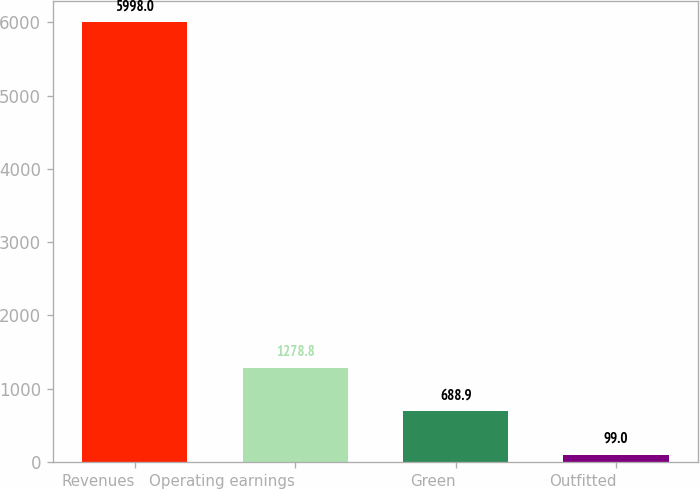Convert chart. <chart><loc_0><loc_0><loc_500><loc_500><bar_chart><fcel>Revenues<fcel>Operating earnings<fcel>Green<fcel>Outfitted<nl><fcel>5998<fcel>1278.8<fcel>688.9<fcel>99<nl></chart> 